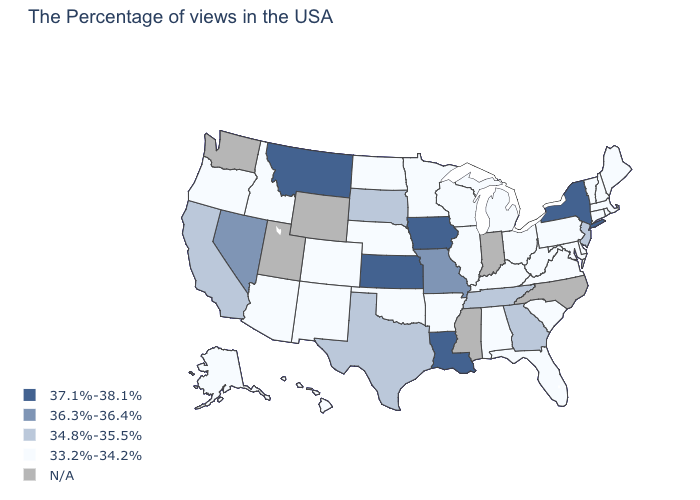Which states hav the highest value in the Northeast?
Answer briefly. New York. What is the highest value in the USA?
Quick response, please. 37.1%-38.1%. Does the map have missing data?
Answer briefly. Yes. What is the value of Wisconsin?
Short answer required. 33.2%-34.2%. What is the value of New Jersey?
Concise answer only. 34.8%-35.5%. Which states have the lowest value in the USA?
Answer briefly. Maine, Massachusetts, Rhode Island, New Hampshire, Vermont, Connecticut, Delaware, Maryland, Pennsylvania, Virginia, South Carolina, West Virginia, Ohio, Florida, Michigan, Kentucky, Alabama, Wisconsin, Illinois, Arkansas, Minnesota, Nebraska, Oklahoma, North Dakota, Colorado, New Mexico, Arizona, Idaho, Oregon, Alaska, Hawaii. Which states have the highest value in the USA?
Keep it brief. New York, Louisiana, Iowa, Kansas, Montana. Among the states that border Delaware , which have the highest value?
Write a very short answer. New Jersey. How many symbols are there in the legend?
Quick response, please. 5. Does the first symbol in the legend represent the smallest category?
Quick response, please. No. Name the states that have a value in the range 37.1%-38.1%?
Be succinct. New York, Louisiana, Iowa, Kansas, Montana. What is the value of New Hampshire?
Quick response, please. 33.2%-34.2%. Among the states that border Arkansas , does Louisiana have the lowest value?
Give a very brief answer. No. Name the states that have a value in the range 34.8%-35.5%?
Short answer required. New Jersey, Georgia, Tennessee, Texas, South Dakota, California. 